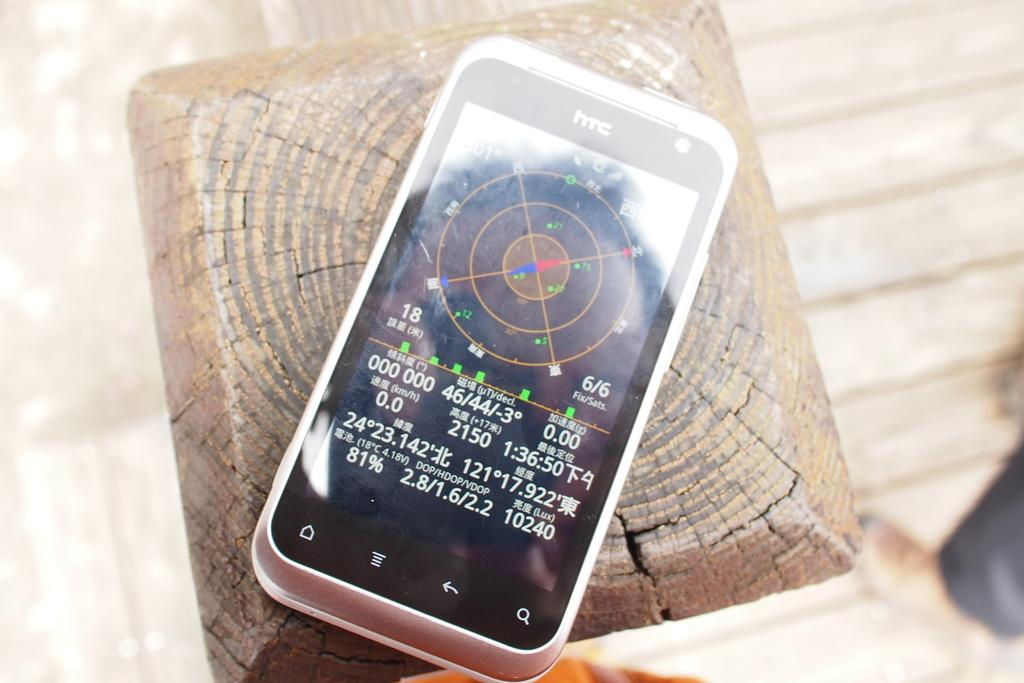<image>
Render a clear and concise summary of the photo. the screen of an HTC branded cell phone with coordinates on the bottom of the screen. 